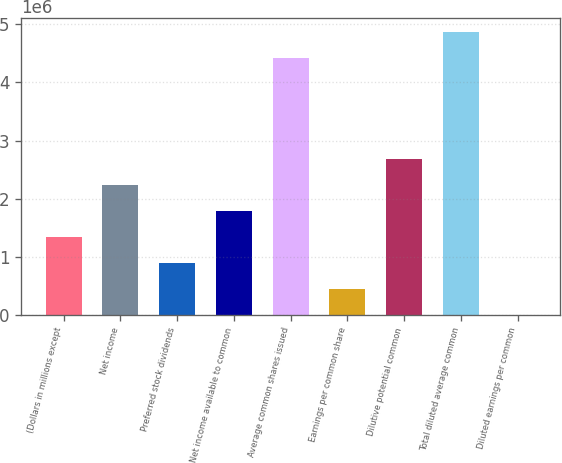<chart> <loc_0><loc_0><loc_500><loc_500><bar_chart><fcel>(Dollars in millions except<fcel>Net income<fcel>Preferred stock dividends<fcel>Net income available to common<fcel>Average common shares issued<fcel>Earnings per common share<fcel>Dilutive potential common<fcel>Total diluted average common<fcel>Diluted earnings per common<nl><fcel>1.34408e+06<fcel>2.24013e+06<fcel>896053<fcel>1.7921e+06<fcel>4.42358e+06<fcel>448028<fcel>2.68815e+06<fcel>4.8716e+06<fcel>3.3<nl></chart> 